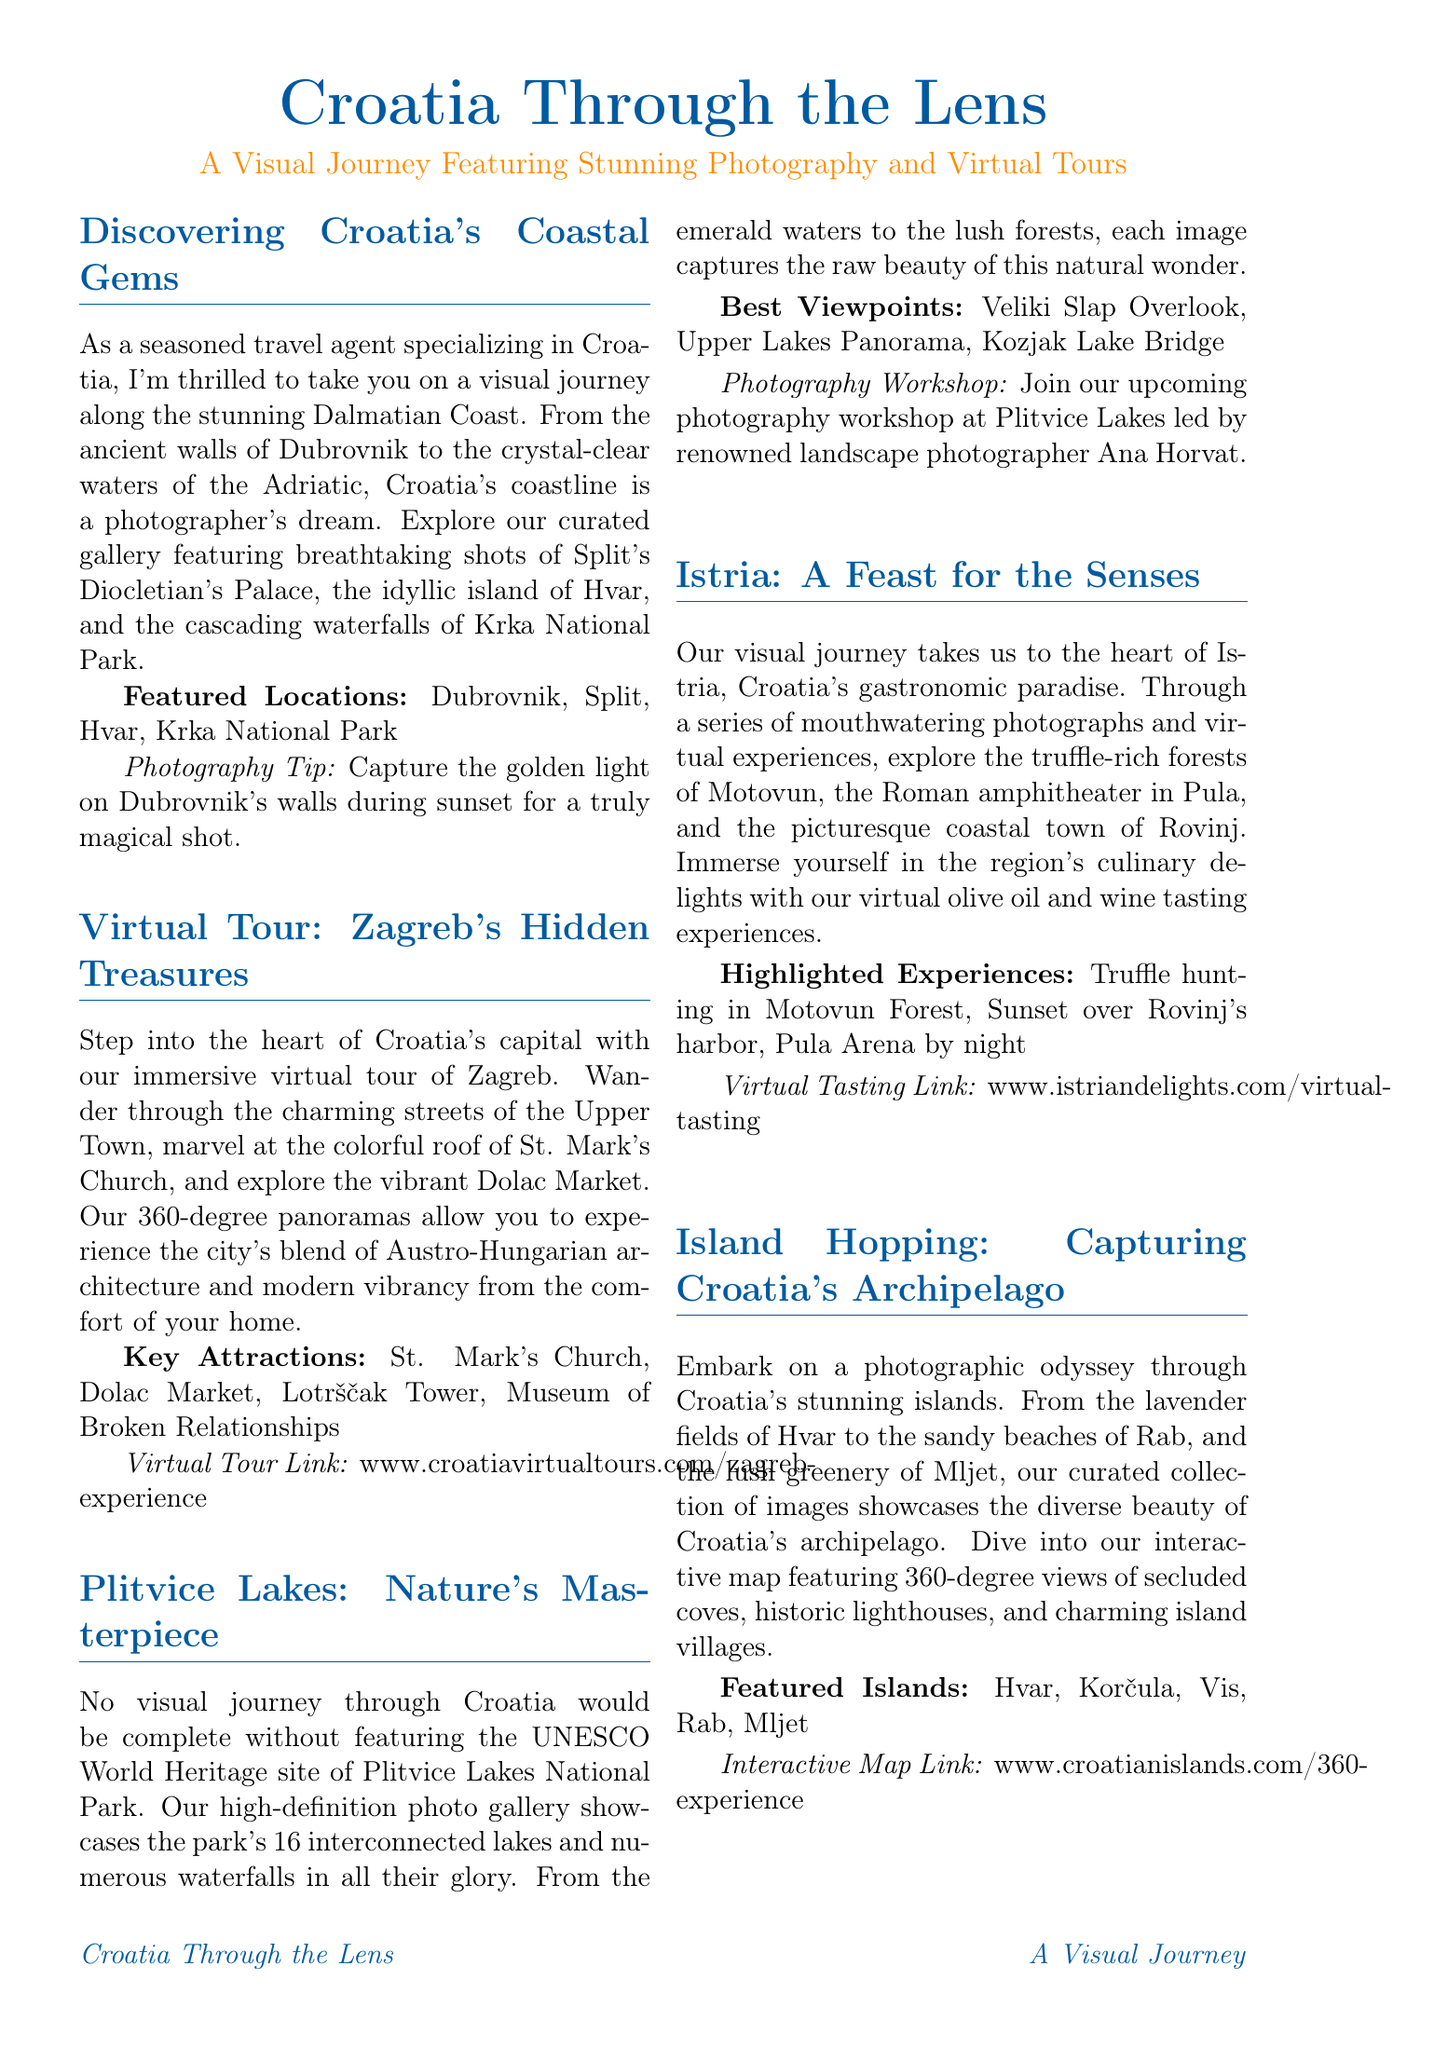What are the featured locations along the Dalmatian Coast? The document lists specific locations that are featured in the coastal journey section.
Answer: Dubrovnik, Split, Hvar, Krka National Park What is the photographer's name mentioned in the exclusive interview? The document highlights a specific photographer and mentions the exclusive interview title.
Answer: Ivo Biočina Which virtual tour can you experience from home? The document specifies a virtual tour related to a particular city's attractions that can be accessed online.
Answer: Zagreb's Hidden Treasures What UNESCO World Heritage site is featured in the document? The document specifically mentions the site's name in relation to its natural beauty.
Answer: Plitvice Lakes National Park What culinary experiences are highlighted in Istria? The document discusses specific experiences related to gastronomy in Istria.
Answer: Olive oil and wine tasting How many interconnected lakes are in Plitvice Lakes National Park? The document specifies the number of lakes present in the park's description.
Answer: 16 What is the name of the amphitheater located in Pula? The document mentions a specific historical structure in the context of Istria's attractions.
Answer: Pula Arena What type of photography workshop is mentioned in the document? The document outlines a specific workshop type and its topic within Plitvice Lakes.
Answer: Photography workshop Which two renowned photographers are featured in the newsletter? The document lists photographers known for their work related to Croatia.
Answer: Ivo Biočina, Luka Esenko 